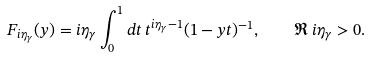<formula> <loc_0><loc_0><loc_500><loc_500>F _ { i \eta _ { \gamma } } ( y ) = i \eta _ { \gamma } \int _ { 0 } ^ { 1 } d t \, t ^ { i \eta _ { \gamma } - 1 } ( 1 - y t ) ^ { - 1 } , \quad \Re \, i \eta _ { \gamma } > 0 .</formula> 